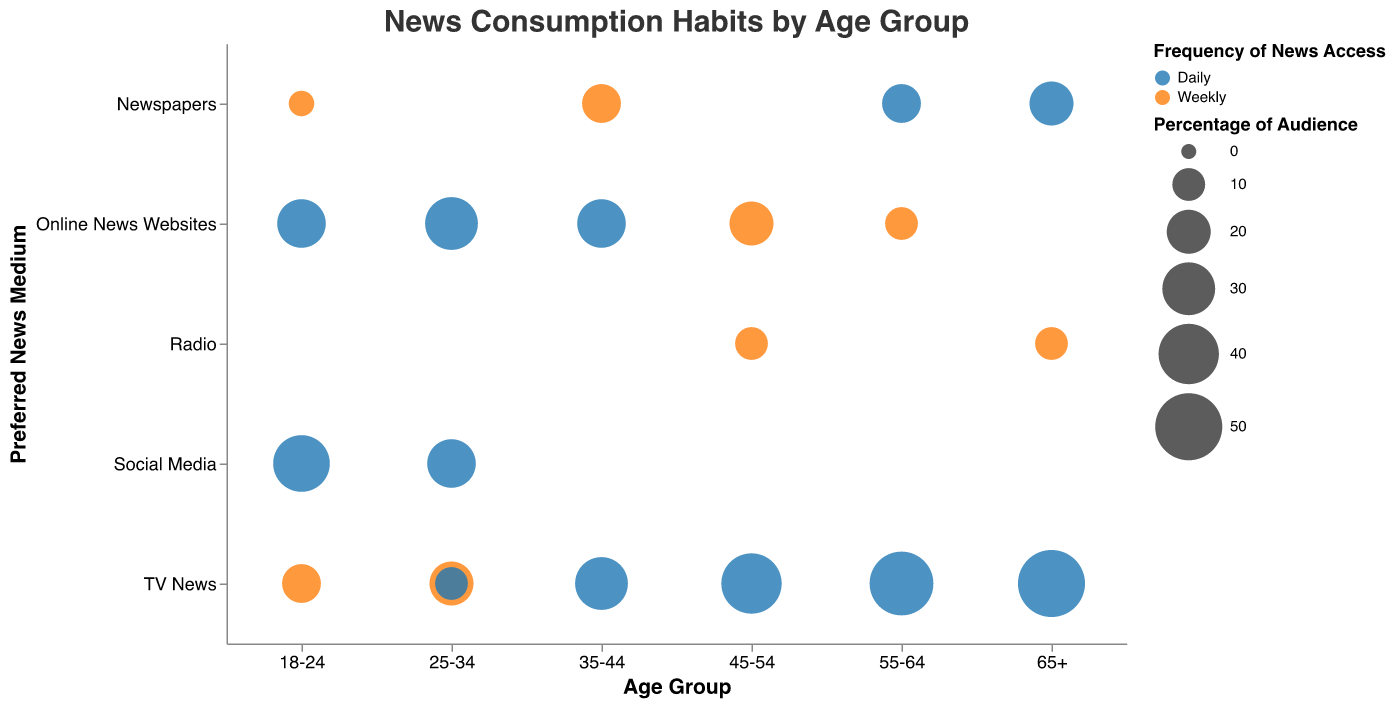What age group has the highest percentage of the audience preferring TV News on a daily basis? By observing the bubble chart, look for the largest circle under TV News on the daily frequency scale. This is in the 65+ age group with a size indicating 50% of the audience.
Answer: 65+ Which age group prefers Online News Websites daily the most? Check the circles for Online News Websites under the daily frequency. The largest circle is in the 25-34 age group, representing 30% of the audience.
Answer: 25-34 What is the combined percentage of the audience that prefers TV News on a daily basis for the 45-54 and 55-64 age groups? Add the percentage of the audience for TV News daily in both the 45-54 and 55-64 age groups: 40% (45-54) + 45% (55-64) = 85%.
Answer: 85% Which age group has the least preference for Newspapers on a weekly basis? Look for the circle with the smallest size under the Newspapers category with a weekly frequency. The 18-24 age group has the smallest circle representing 5% of the audience.
Answer: 18-24 Among the 35-44 and 45-54 age groups, which has a greater audience percentage for Online News Websites on a daily basis? Compare the sizes of circles under Online News Websites with a daily frequency for the 35-44 and 45-54 age groups. The 35-44 age group has a larger circle with 25%.
Answer: 35-44 How do the preferences for Social Media daily compare between age groups 18-24 and 25-34? Compare the sizes of the circles under Social Media on a daily frequency for the 18-24 and 25-34 age groups. The 18-24 age group has a larger circle representing 35%, whereas the 25-34 age group has 25%.
Answer: 18-24 What's the difference in percentage of the audience that prefers TV News weekly between the 18-24 and 25-34 age groups? Subtract the percentage of the audience for TV News weekly in the 18-24 age group (15%) from that in the 25-34 age group (20%). 20% - 15% = 5%.
Answer: 5% In which age group is the preference for Radio weekly the highest? Look at the circles under Radio with a weekly frequency across age groups. The largest circle is in the 45-54 and 65+ age groups, each representing 10% of the audience.
Answer: 45-54 and 65+ How does the frequency of news access (daily vs. weekly) impact the audience size for Newspapers in the 65+ age group? Compare the sizes of circles in the Newspapers category for daily and weekly frequency in the 65+ age group. The daily frequency circle is much larger, representing 20%, while there is no circle for weekly frequency, indicating a preference for daily over weekly in this age group.
Answer: Daily preferred (20%) Considering all age groups, what is the least preferred news medium on a daily basis? Identify the smallest circles under the daily frequency across different news mediums. Newspapers generally have the smallest daily audience, with the highest being 20% for the 65+ age group.
Answer: Newspapers 